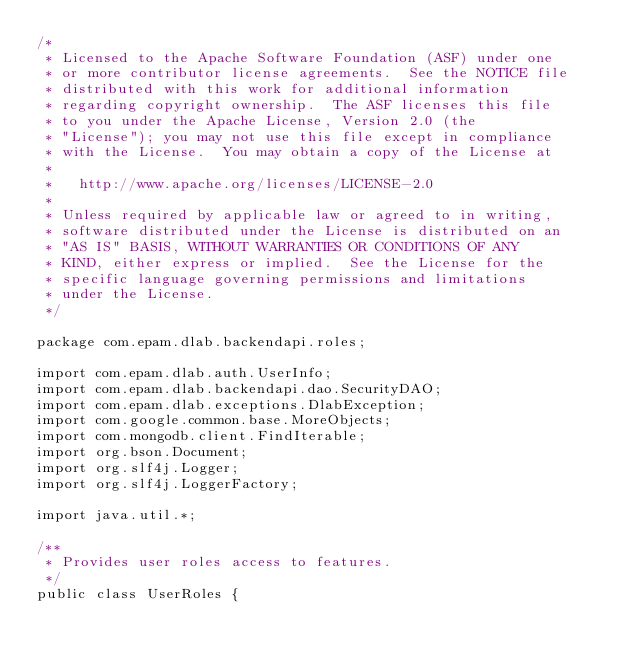Convert code to text. <code><loc_0><loc_0><loc_500><loc_500><_Java_>/*
 * Licensed to the Apache Software Foundation (ASF) under one
 * or more contributor license agreements.  See the NOTICE file
 * distributed with this work for additional information
 * regarding copyright ownership.  The ASF licenses this file
 * to you under the Apache License, Version 2.0 (the
 * "License"); you may not use this file except in compliance
 * with the License.  You may obtain a copy of the License at
 *
 *   http://www.apache.org/licenses/LICENSE-2.0
 *
 * Unless required by applicable law or agreed to in writing,
 * software distributed under the License is distributed on an
 * "AS IS" BASIS, WITHOUT WARRANTIES OR CONDITIONS OF ANY
 * KIND, either express or implied.  See the License for the
 * specific language governing permissions and limitations
 * under the License.
 */

package com.epam.dlab.backendapi.roles;

import com.epam.dlab.auth.UserInfo;
import com.epam.dlab.backendapi.dao.SecurityDAO;
import com.epam.dlab.exceptions.DlabException;
import com.google.common.base.MoreObjects;
import com.mongodb.client.FindIterable;
import org.bson.Document;
import org.slf4j.Logger;
import org.slf4j.LoggerFactory;

import java.util.*;

/**
 * Provides user roles access to features.
 */
public class UserRoles {</code> 